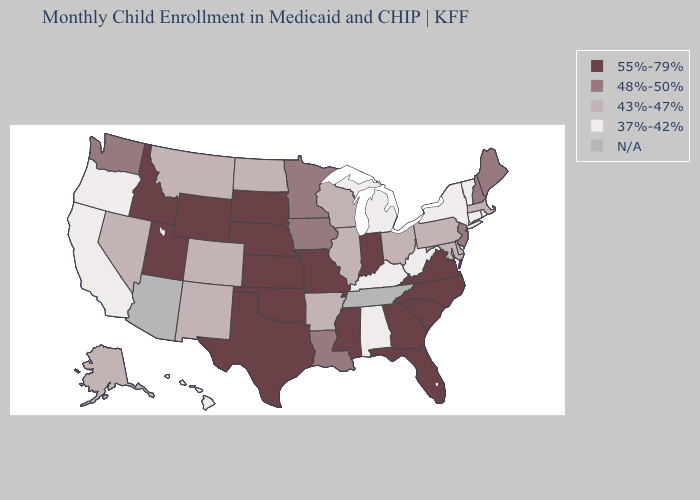Name the states that have a value in the range 55%-79%?
Quick response, please. Florida, Georgia, Idaho, Indiana, Kansas, Mississippi, Missouri, Nebraska, North Carolina, Oklahoma, South Carolina, South Dakota, Texas, Utah, Virginia, Wyoming. Which states have the lowest value in the South?
Concise answer only. Alabama, Kentucky, West Virginia. What is the value of Indiana?
Be succinct. 55%-79%. What is the value of Mississippi?
Answer briefly. 55%-79%. What is the value of North Dakota?
Quick response, please. 43%-47%. What is the value of Iowa?
Be succinct. 48%-50%. Which states have the lowest value in the South?
Short answer required. Alabama, Kentucky, West Virginia. Name the states that have a value in the range N/A?
Write a very short answer. Arizona, Tennessee. Among the states that border Utah , does New Mexico have the lowest value?
Be succinct. Yes. Name the states that have a value in the range N/A?
Write a very short answer. Arizona, Tennessee. What is the value of New Mexico?
Be succinct. 43%-47%. Among the states that border Oregon , does California have the lowest value?
Keep it brief. Yes. How many symbols are there in the legend?
Quick response, please. 5. Which states have the highest value in the USA?
Short answer required. Florida, Georgia, Idaho, Indiana, Kansas, Mississippi, Missouri, Nebraska, North Carolina, Oklahoma, South Carolina, South Dakota, Texas, Utah, Virginia, Wyoming. 